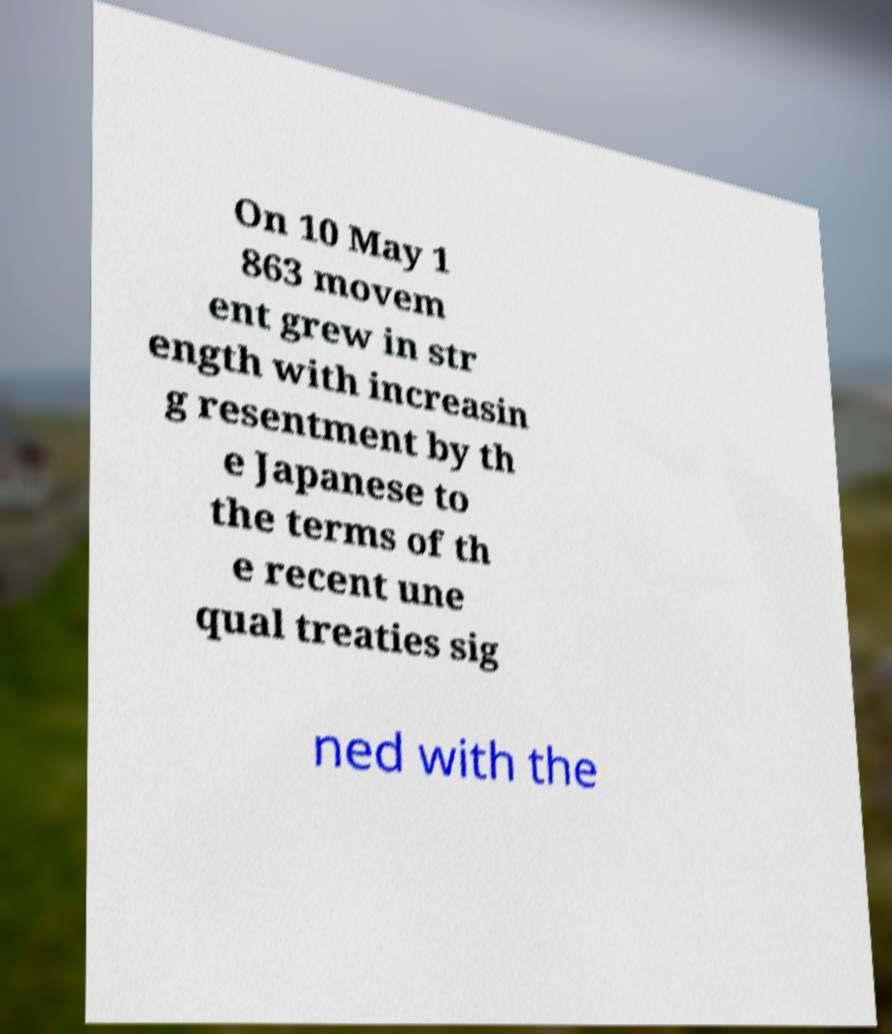Can you accurately transcribe the text from the provided image for me? On 10 May 1 863 movem ent grew in str ength with increasin g resentment by th e Japanese to the terms of th e recent une qual treaties sig ned with the 